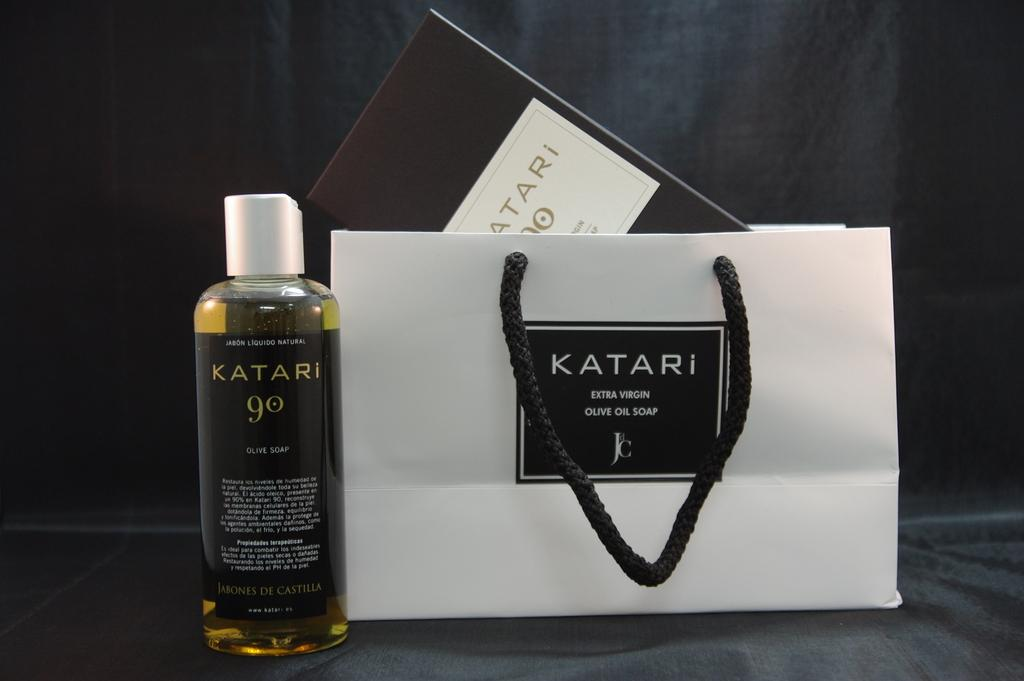<image>
Share a concise interpretation of the image provided. A Katari bag is next to a bottle of Katari 90. 